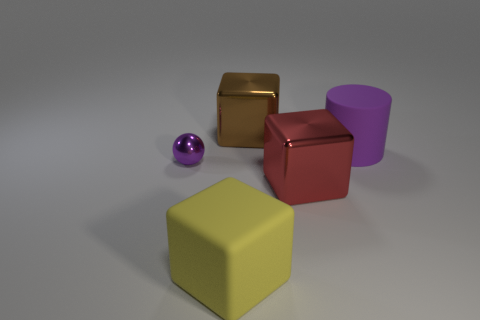Subtract all big metallic blocks. How many blocks are left? 1 Add 2 yellow matte objects. How many objects exist? 7 Subtract all balls. How many objects are left? 4 Subtract all blue blocks. Subtract all cyan balls. How many blocks are left? 3 Subtract 0 blue cylinders. How many objects are left? 5 Subtract all brown things. Subtract all large yellow matte things. How many objects are left? 3 Add 2 cubes. How many cubes are left? 5 Add 4 tiny purple matte cylinders. How many tiny purple matte cylinders exist? 4 